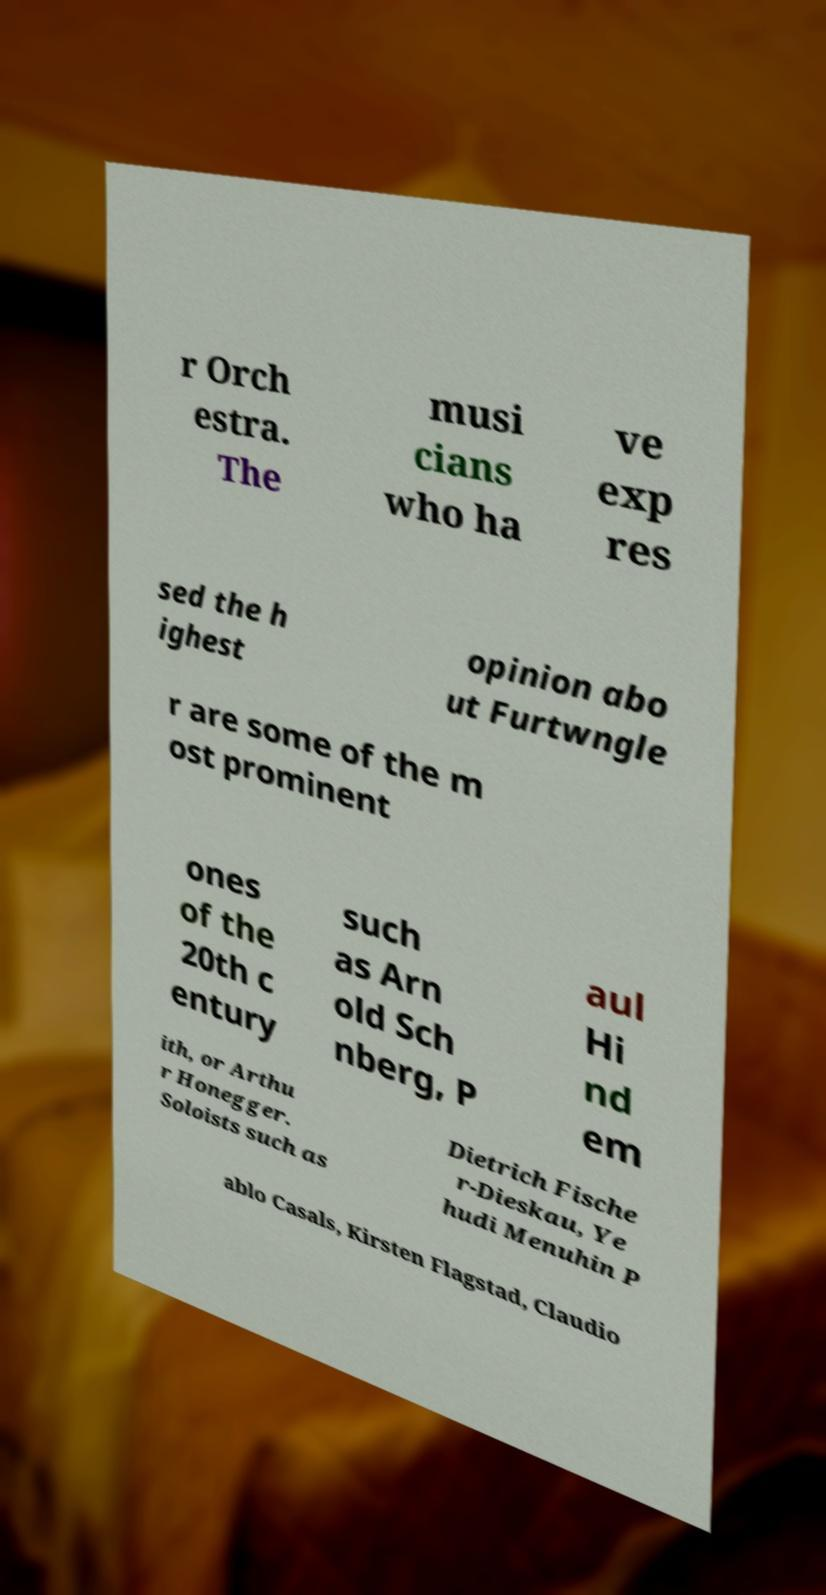Can you accurately transcribe the text from the provided image for me? r Orch estra. The musi cians who ha ve exp res sed the h ighest opinion abo ut Furtwngle r are some of the m ost prominent ones of the 20th c entury such as Arn old Sch nberg, P aul Hi nd em ith, or Arthu r Honegger. Soloists such as Dietrich Fische r-Dieskau, Ye hudi Menuhin P ablo Casals, Kirsten Flagstad, Claudio 